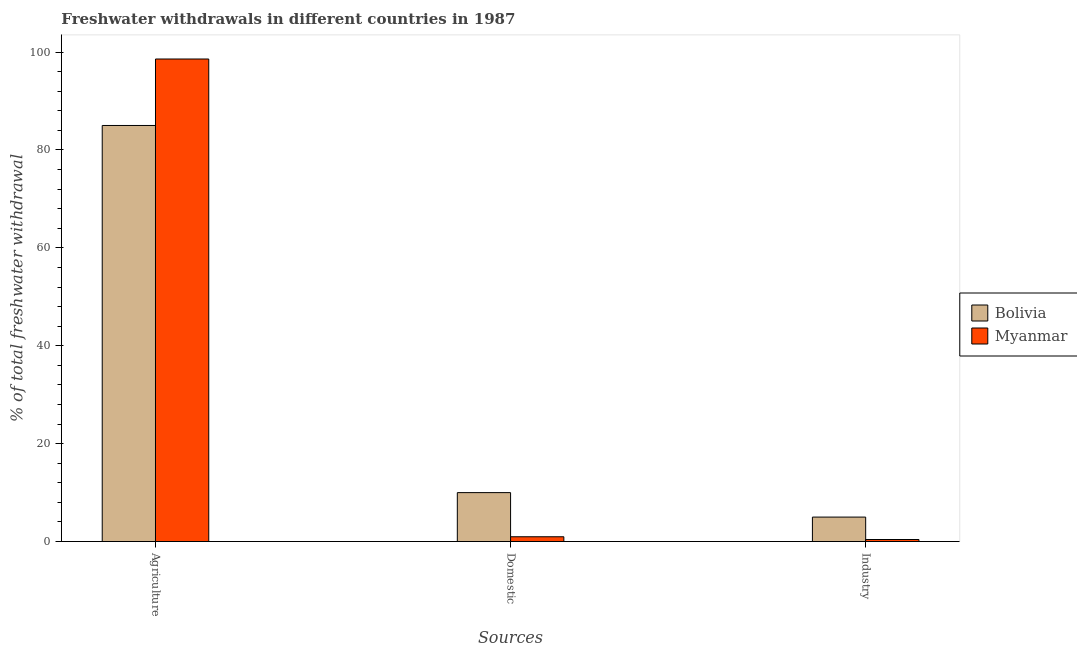How many different coloured bars are there?
Provide a succinct answer. 2. Are the number of bars per tick equal to the number of legend labels?
Offer a very short reply. Yes. How many bars are there on the 2nd tick from the right?
Provide a short and direct response. 2. What is the label of the 1st group of bars from the left?
Provide a short and direct response. Agriculture. What is the percentage of freshwater withdrawal for agriculture in Myanmar?
Your answer should be compact. 98.58. Across all countries, what is the maximum percentage of freshwater withdrawal for agriculture?
Offer a very short reply. 98.58. Across all countries, what is the minimum percentage of freshwater withdrawal for domestic purposes?
Give a very brief answer. 0.98. In which country was the percentage of freshwater withdrawal for industry minimum?
Provide a short and direct response. Myanmar. What is the total percentage of freshwater withdrawal for domestic purposes in the graph?
Ensure brevity in your answer.  10.98. What is the difference between the percentage of freshwater withdrawal for industry in Bolivia and that in Myanmar?
Your answer should be compact. 4.58. What is the difference between the percentage of freshwater withdrawal for industry in Myanmar and the percentage of freshwater withdrawal for agriculture in Bolivia?
Make the answer very short. -84.58. What is the average percentage of freshwater withdrawal for agriculture per country?
Make the answer very short. 91.79. What is the difference between the percentage of freshwater withdrawal for industry and percentage of freshwater withdrawal for domestic purposes in Bolivia?
Ensure brevity in your answer.  -5. What is the ratio of the percentage of freshwater withdrawal for industry in Bolivia to that in Myanmar?
Give a very brief answer. 11.89. What is the difference between the highest and the second highest percentage of freshwater withdrawal for industry?
Make the answer very short. 4.58. What is the difference between the highest and the lowest percentage of freshwater withdrawal for agriculture?
Your response must be concise. 13.58. What does the 2nd bar from the left in Domestic represents?
Offer a terse response. Myanmar. What does the 2nd bar from the right in Agriculture represents?
Your response must be concise. Bolivia. How many bars are there?
Offer a terse response. 6. What is the difference between two consecutive major ticks on the Y-axis?
Ensure brevity in your answer.  20. Does the graph contain grids?
Give a very brief answer. No. Where does the legend appear in the graph?
Provide a succinct answer. Center right. How many legend labels are there?
Offer a terse response. 2. How are the legend labels stacked?
Keep it short and to the point. Vertical. What is the title of the graph?
Ensure brevity in your answer.  Freshwater withdrawals in different countries in 1987. What is the label or title of the X-axis?
Your answer should be compact. Sources. What is the label or title of the Y-axis?
Offer a terse response. % of total freshwater withdrawal. What is the % of total freshwater withdrawal of Myanmar in Agriculture?
Your answer should be compact. 98.58. What is the % of total freshwater withdrawal in Myanmar in Domestic?
Your answer should be very brief. 0.98. What is the % of total freshwater withdrawal in Bolivia in Industry?
Ensure brevity in your answer.  5. What is the % of total freshwater withdrawal of Myanmar in Industry?
Offer a terse response. 0.42. Across all Sources, what is the maximum % of total freshwater withdrawal of Myanmar?
Your answer should be very brief. 98.58. Across all Sources, what is the minimum % of total freshwater withdrawal in Bolivia?
Offer a terse response. 5. Across all Sources, what is the minimum % of total freshwater withdrawal of Myanmar?
Offer a terse response. 0.42. What is the total % of total freshwater withdrawal in Bolivia in the graph?
Offer a terse response. 100. What is the total % of total freshwater withdrawal in Myanmar in the graph?
Provide a succinct answer. 99.98. What is the difference between the % of total freshwater withdrawal of Bolivia in Agriculture and that in Domestic?
Keep it short and to the point. 75. What is the difference between the % of total freshwater withdrawal in Myanmar in Agriculture and that in Domestic?
Ensure brevity in your answer.  97.6. What is the difference between the % of total freshwater withdrawal of Bolivia in Agriculture and that in Industry?
Provide a succinct answer. 80. What is the difference between the % of total freshwater withdrawal of Myanmar in Agriculture and that in Industry?
Provide a succinct answer. 98.16. What is the difference between the % of total freshwater withdrawal in Myanmar in Domestic and that in Industry?
Provide a short and direct response. 0.56. What is the difference between the % of total freshwater withdrawal in Bolivia in Agriculture and the % of total freshwater withdrawal in Myanmar in Domestic?
Your response must be concise. 84.02. What is the difference between the % of total freshwater withdrawal of Bolivia in Agriculture and the % of total freshwater withdrawal of Myanmar in Industry?
Provide a succinct answer. 84.58. What is the difference between the % of total freshwater withdrawal in Bolivia in Domestic and the % of total freshwater withdrawal in Myanmar in Industry?
Your answer should be compact. 9.58. What is the average % of total freshwater withdrawal of Bolivia per Sources?
Ensure brevity in your answer.  33.33. What is the average % of total freshwater withdrawal of Myanmar per Sources?
Your response must be concise. 33.33. What is the difference between the % of total freshwater withdrawal of Bolivia and % of total freshwater withdrawal of Myanmar in Agriculture?
Offer a terse response. -13.58. What is the difference between the % of total freshwater withdrawal in Bolivia and % of total freshwater withdrawal in Myanmar in Domestic?
Your response must be concise. 9.02. What is the difference between the % of total freshwater withdrawal of Bolivia and % of total freshwater withdrawal of Myanmar in Industry?
Give a very brief answer. 4.58. What is the ratio of the % of total freshwater withdrawal of Bolivia in Agriculture to that in Domestic?
Your answer should be very brief. 8.5. What is the ratio of the % of total freshwater withdrawal of Myanmar in Agriculture to that in Domestic?
Provide a succinct answer. 100.5. What is the ratio of the % of total freshwater withdrawal of Myanmar in Agriculture to that in Industry?
Keep it short and to the point. 234.49. What is the ratio of the % of total freshwater withdrawal in Bolivia in Domestic to that in Industry?
Your answer should be compact. 2. What is the ratio of the % of total freshwater withdrawal of Myanmar in Domestic to that in Industry?
Your response must be concise. 2.33. What is the difference between the highest and the second highest % of total freshwater withdrawal of Bolivia?
Make the answer very short. 75. What is the difference between the highest and the second highest % of total freshwater withdrawal of Myanmar?
Make the answer very short. 97.6. What is the difference between the highest and the lowest % of total freshwater withdrawal in Myanmar?
Offer a very short reply. 98.16. 